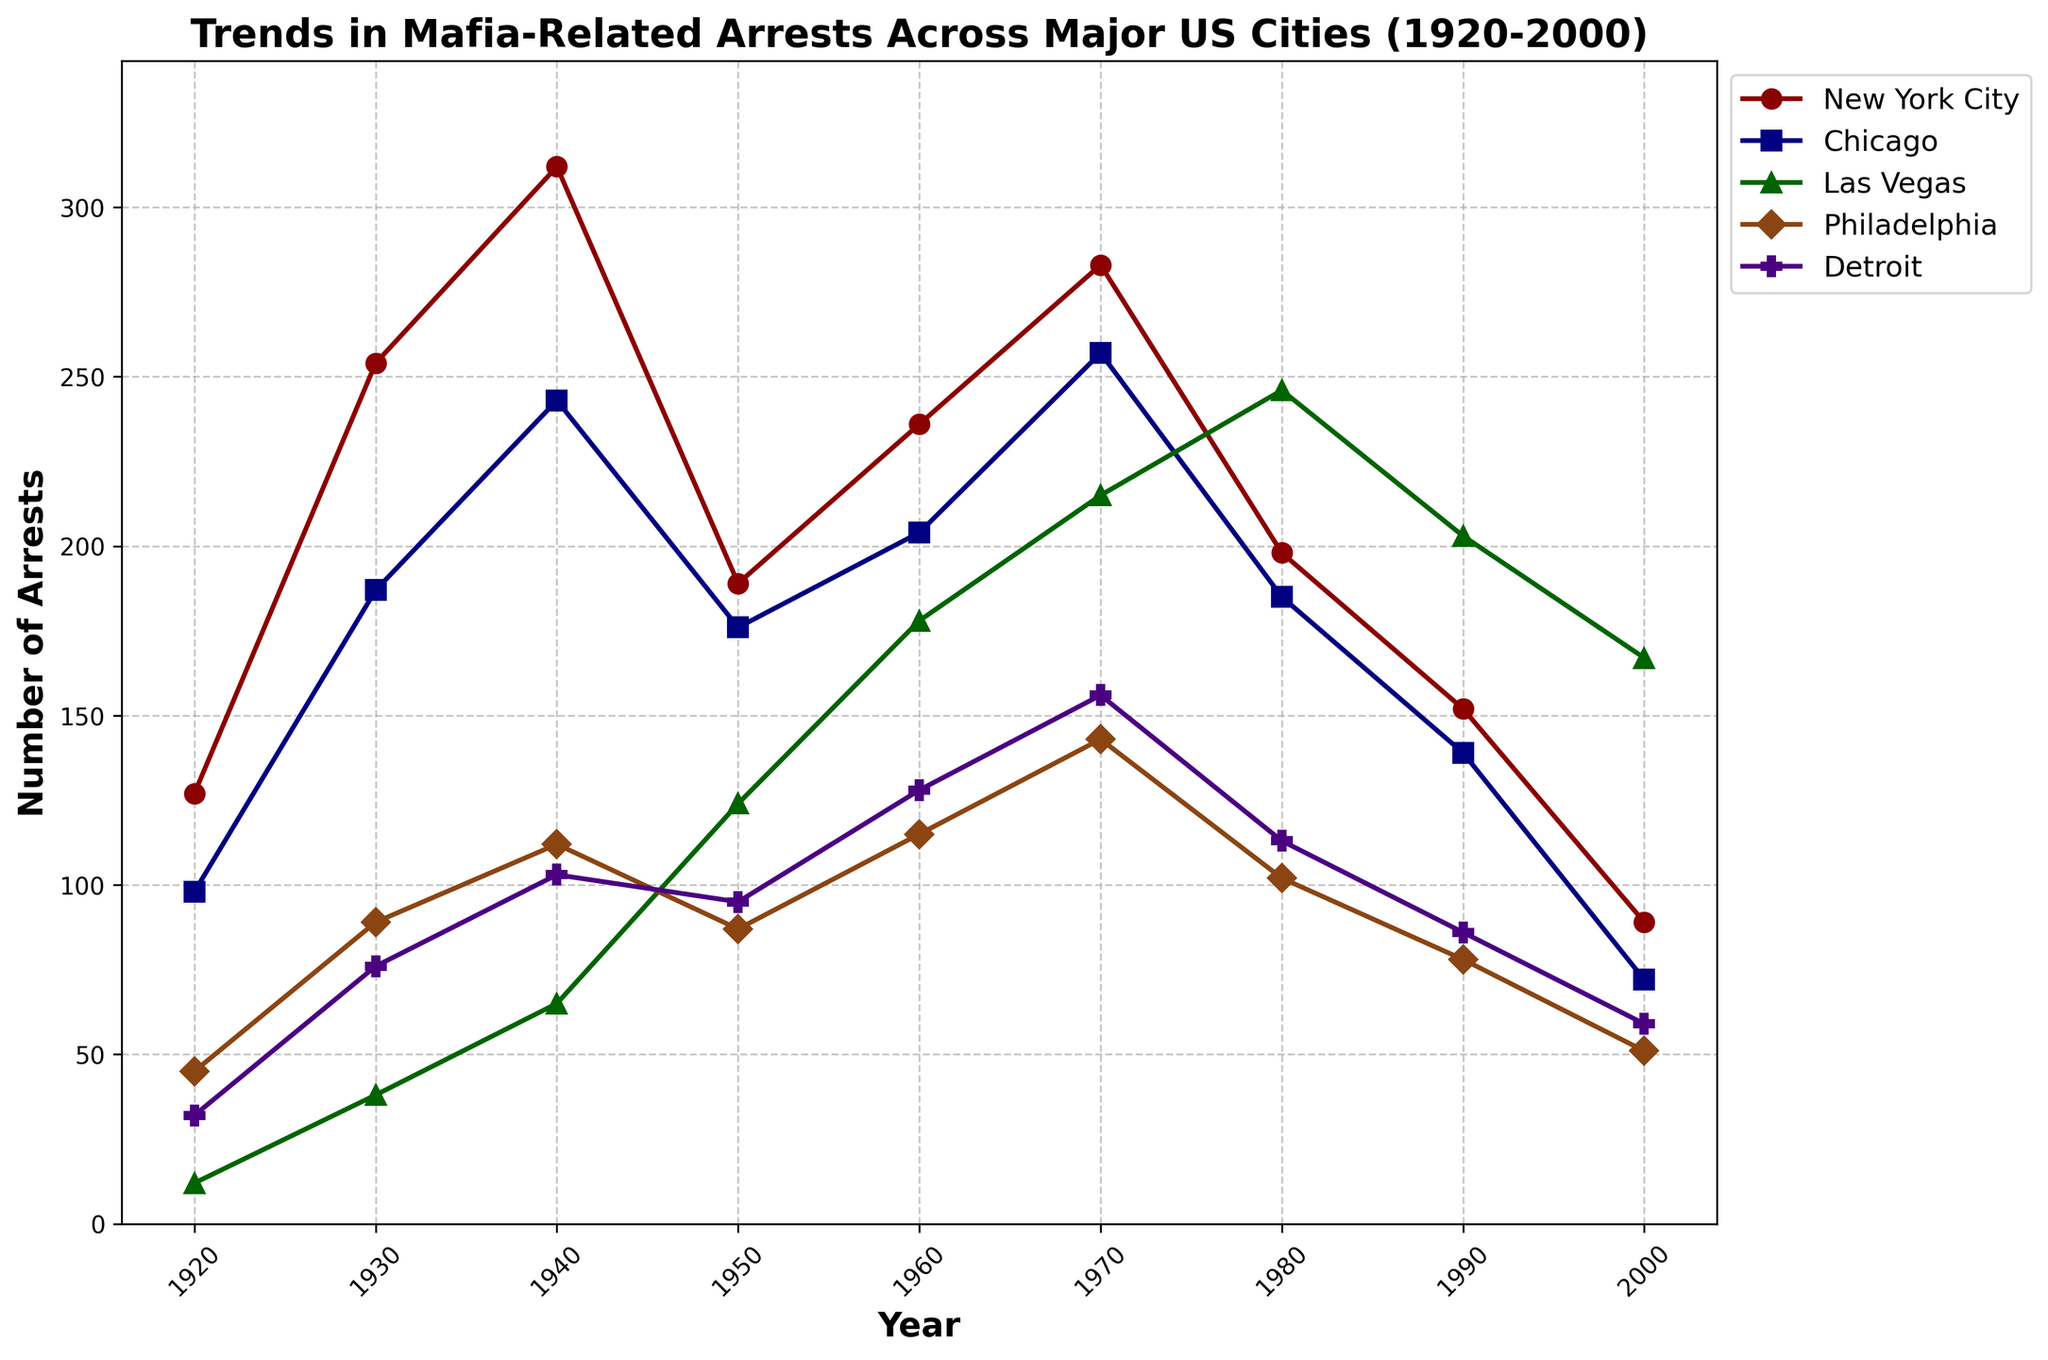What's the trend in New York City arrests over time? In 1920, the number of arrests starts at 127 and rises to a peak of 312 in 1940. It then drops to 189 in 1950, increases again to 283 in 1970, and subsequently declines to 89 by 2000.
Answer: Decline after 1930s Which city had the highest number of mafia-related arrests in 1980? To find this, look at the data points for each city in 1980. New York City had 198, Chicago had 185, Las Vegas had 246, Philadelphia had 102, and Detroit had 113. Las Vegas had the highest number of arrests in 1980.
Answer: Las Vegas How did the trend in mafia-related arrests in Detroit change from 1920 to 2000? In Detroit, the number of arrests was 32 in 1920. It increased gradually to 156 in 1970, and then trended downward to 59 by 2000.
Answer: Initial increase followed by a decline after 1970 In which decade did Chicago see its highest recorded arrests? Look across points in the line plot for Chicago from 1920 to 2000. The highest point is at 1930 with a peak of 243 arrests.
Answer: 1940 What is the difference in arrests between New York City and Philadelphia in 1940? Subtract the number of arrests in Philadelphia from New York City in 1940. NYC: 312, Philadelphia: 112, giving a difference of 312 - 112 = 200.
Answer: 200 Which city showed a continuous increase in arrests from 1920 to 1980? Examine the lines for each city from 1920 to 1980. Las Vegas shows a continuous increase in arrests during this period.
Answer: Las Vegas What is the average number of arrests in Chicago during the 20th century? Sum the number of arrests in Chicago from 1920 to 2000, then divide by the number of data points (9 data points). (98 + 187 + 243 + 176 + 204 + 257 + 185 + 139 + 72)/9 = 1734/9 ≈ 193
Answer: 193 Which city had the steepest decline in arrests from 1970 to 2000? Compare the difference in arrests from 1970 to 2000 for each city. New York City had 283 in 1970 and 89 in 2000, making a decline of 194, which is larger than other cities.
Answer: New York City In 1950, how do the arrests in Las Vegas compare to those in Detroit? Look at the arrests for Las Vegas and Detroit in 1950. Las Vegas had 124 arrests while Detroit had 95. Las Vegas had more arrests compared to Detroit in that year.
Answer: Las Vegas had more What's the trend for Philadelphia arrests in the 1990s? For Philadelphia, the number of arrests was 78 in 1990 and dropped to 51 in 2000, showing a declining trend.
Answer: Decline 